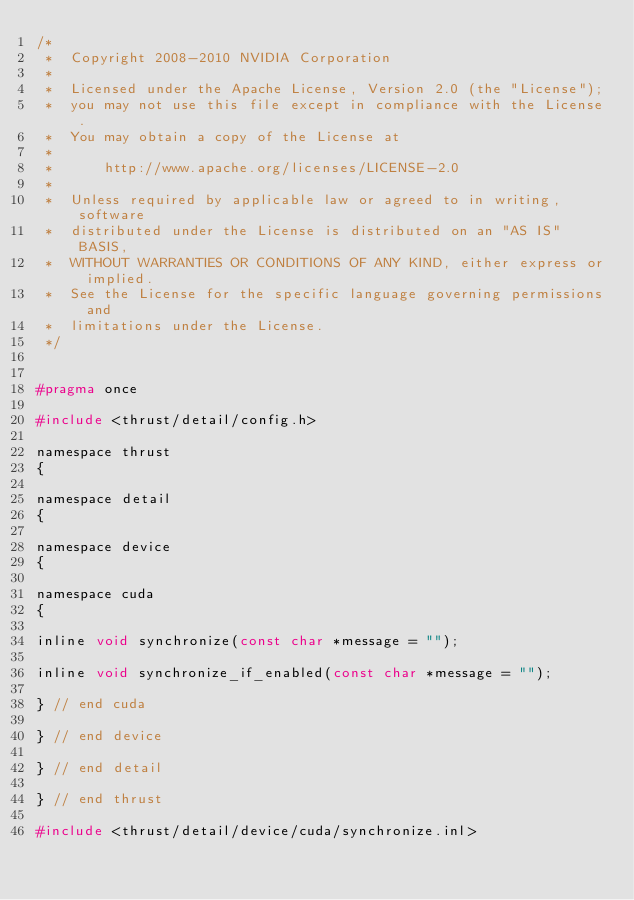Convert code to text. <code><loc_0><loc_0><loc_500><loc_500><_C_>/*
 *  Copyright 2008-2010 NVIDIA Corporation
 *
 *  Licensed under the Apache License, Version 2.0 (the "License");
 *  you may not use this file except in compliance with the License.
 *  You may obtain a copy of the License at
 *
 *      http://www.apache.org/licenses/LICENSE-2.0
 *
 *  Unless required by applicable law or agreed to in writing, software
 *  distributed under the License is distributed on an "AS IS" BASIS,
 *  WITHOUT WARRANTIES OR CONDITIONS OF ANY KIND, either express or implied.
 *  See the License for the specific language governing permissions and
 *  limitations under the License.
 */


#pragma once

#include <thrust/detail/config.h>

namespace thrust
{

namespace detail
{

namespace device
{

namespace cuda
{

inline void synchronize(const char *message = "");

inline void synchronize_if_enabled(const char *message = "");

} // end cuda

} // end device

} // end detail

} // end thrust

#include <thrust/detail/device/cuda/synchronize.inl>

</code> 